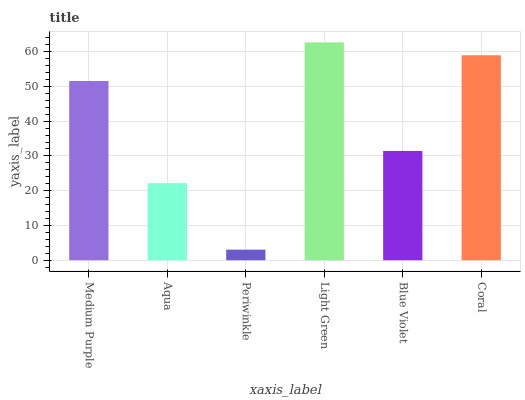Is Periwinkle the minimum?
Answer yes or no. Yes. Is Light Green the maximum?
Answer yes or no. Yes. Is Aqua the minimum?
Answer yes or no. No. Is Aqua the maximum?
Answer yes or no. No. Is Medium Purple greater than Aqua?
Answer yes or no. Yes. Is Aqua less than Medium Purple?
Answer yes or no. Yes. Is Aqua greater than Medium Purple?
Answer yes or no. No. Is Medium Purple less than Aqua?
Answer yes or no. No. Is Medium Purple the high median?
Answer yes or no. Yes. Is Blue Violet the low median?
Answer yes or no. Yes. Is Blue Violet the high median?
Answer yes or no. No. Is Periwinkle the low median?
Answer yes or no. No. 